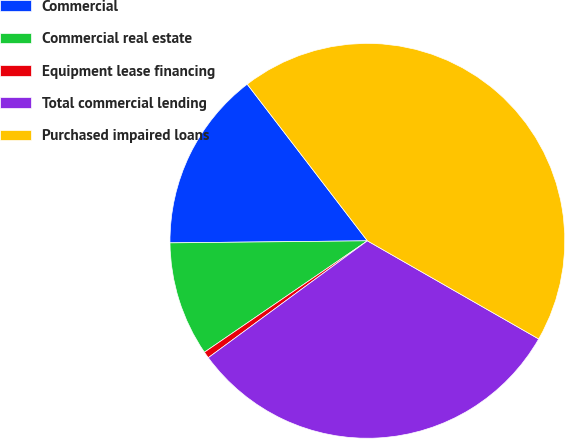Convert chart. <chart><loc_0><loc_0><loc_500><loc_500><pie_chart><fcel>Commercial<fcel>Commercial real estate<fcel>Equipment lease financing<fcel>Total commercial lending<fcel>Purchased impaired loans<nl><fcel>14.75%<fcel>9.38%<fcel>0.54%<fcel>31.64%<fcel>43.7%<nl></chart> 